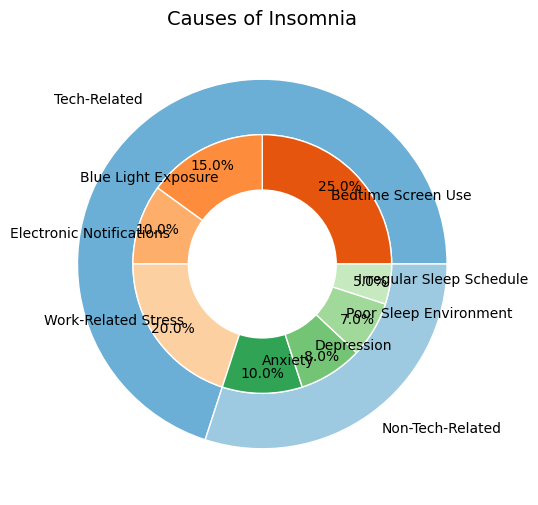Which tech-related factor contributes the most to insomnia? By observing the inner part of the pie chart, we see that "Bedtime Screen Use" is the tech-related factor with the largest section.
Answer: Bedtime Screen Use What is the combined percentage of "Blue Light Exposure" and "Work-Related Stress"? Identify the slices for "Blue Light Exposure" (15%) and "Work-Related Stress" (20%). Adding these values gives 15% + 20% = 35%.
Answer: 35% Which non-tech-related factor contributes the least to insomnia? From the inner circle categorizing non-tech-related factors, the smallest section is "Irregular Sleep Schedule" at 5%.
Answer: Irregular Sleep Schedule Is "Electronic Notifications" a greater cause of insomnia than "Depression"? Compare the slices for "Electronic Notifications" (10%) and "Depression" (8%). "Electronic Notifications" is larger.
Answer: Yes What is the total percentage of insomnia causes under non-tech-related factors? Sum up the percentages of the non-tech-related factors: Anxiety (10%) + Depression (8%) + Poor Sleep Environment (7%) + Irregular Sleep Schedule (5%) = 30%.
Answer: 30% Which category, tech-related or non-tech-related, has a larger cumulative percentage? The outer circles represent the categories. Tech-related factors sum to 70%, while non-tech-related factors sum to 30%. The tech-related category is larger.
Answer: Tech-Related How much more does "Bedtime Screen Use" contribute to insomnia compared to "Poor Sleep Environment"? The percentage for "Bedtime Screen Use" is 25% and for "Poor Sleep Environment" is 7%. The difference is 25% - 7% = 18%.
Answer: 18% What is the percentage difference between the tech-related and non-tech-related categories as a whole? The tech-related category is 70%, and the non-tech-related category is 30%. The difference is 70% - 30% = 40%.
Answer: 40% Which tech-related factors make up half of the total tech-related causes? The total percentage for tech-related factors is 70%. Half of this is 35%. "Bedtime Screen Use" and "Work-Related Stress" together make 45%, covering more than half. The closest to half without exceeding would be "Bedtime Screen Use" (25%) and "Blue Light Exposure" (15%), which together are 40%. However, strictly speaking, some wiggle near the half would mean any combination totaling 35%.
Answer: Bedtime Screen Use and Blue Light Exposure What is the average percentage contribution across all tech-related factors? There are 4 tech-related factors: Bedtime Screen Use (25%), Blue Light Exposure (15%), Electronic Notifications (10%), Work-Related Stress (20%). Sum them up: 25% + 15% + 10% + 20% = 70%, then divide by 4. (70/4 = 17.5%).
Answer: 17.5% What two non-tech-related factors combined are equal to "Bedtime Screen Use"? The percentages for non-tech-related factors are Anxiety (10%), Depression (8%), Poor Sleep Environment (7%), Irregular Sleep Schedule (5%). The sum of Anxiety and Depression (10% + 8% = 18%) is closest to 25% without exceeding it.
Answer: Anxiety and Depression 